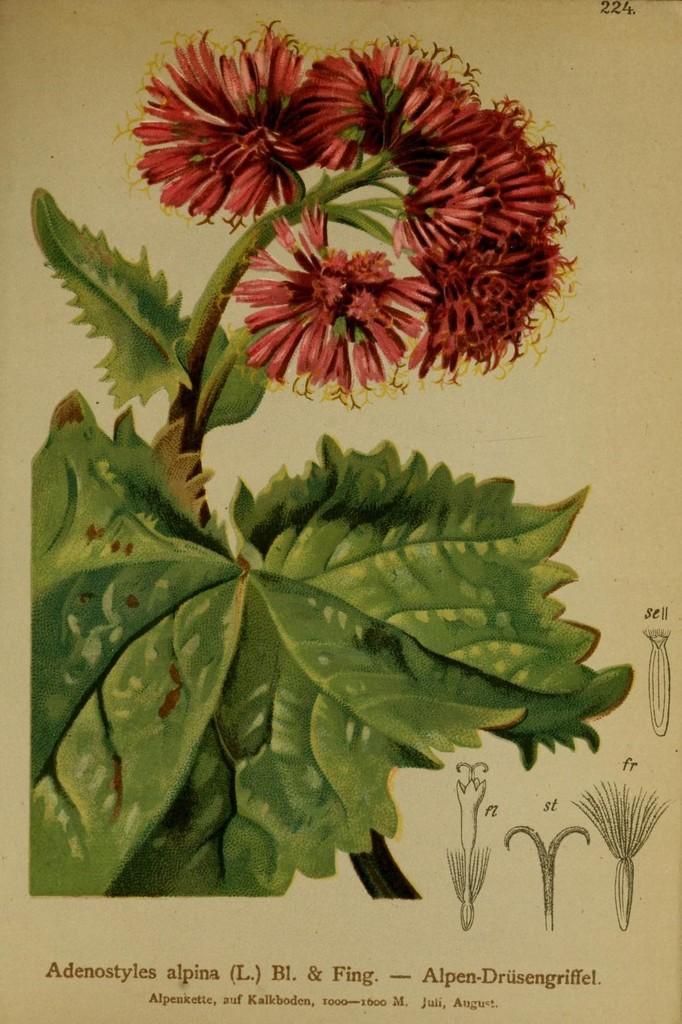How would you summarize this image in a sentence or two? In this image I can see a poster. In this poster I can see a flower plant and flower parts. Something is written on this poster.   